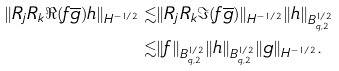Convert formula to latex. <formula><loc_0><loc_0><loc_500><loc_500>\| R _ { j } R _ { k } \Re ( f \overline { g } ) h \| _ { H ^ { - 1 / 2 } } \lesssim & \| R _ { j } R _ { k } \Im ( f \overline { g } ) \| _ { H ^ { - 1 / 2 } } \| h \| _ { B ^ { 1 / 2 } _ { q , 2 } } \\ \lesssim & \| f \| _ { B ^ { 1 / 2 } _ { q , 2 } } \| h \| _ { B ^ { 1 / 2 } _ { q , 2 } } \| g \| _ { H ^ { - 1 / 2 } } .</formula> 